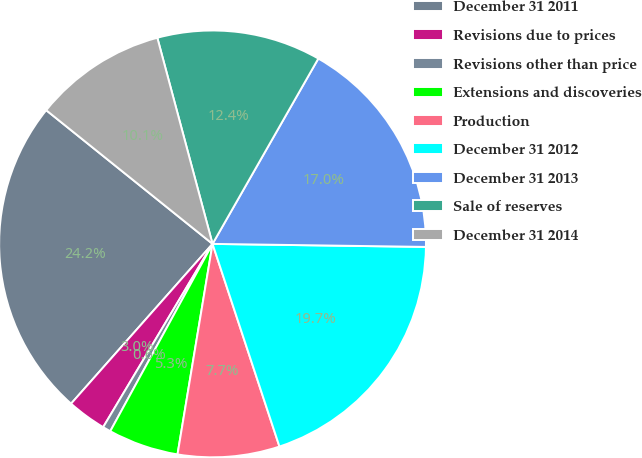Convert chart to OTSL. <chart><loc_0><loc_0><loc_500><loc_500><pie_chart><fcel>December 31 2011<fcel>Revisions due to prices<fcel>Revisions other than price<fcel>Extensions and discoveries<fcel>Production<fcel>December 31 2012<fcel>December 31 2013<fcel>Sale of reserves<fcel>December 31 2014<nl><fcel>24.24%<fcel>2.97%<fcel>0.61%<fcel>5.33%<fcel>7.7%<fcel>19.7%<fcel>16.97%<fcel>12.42%<fcel>10.06%<nl></chart> 